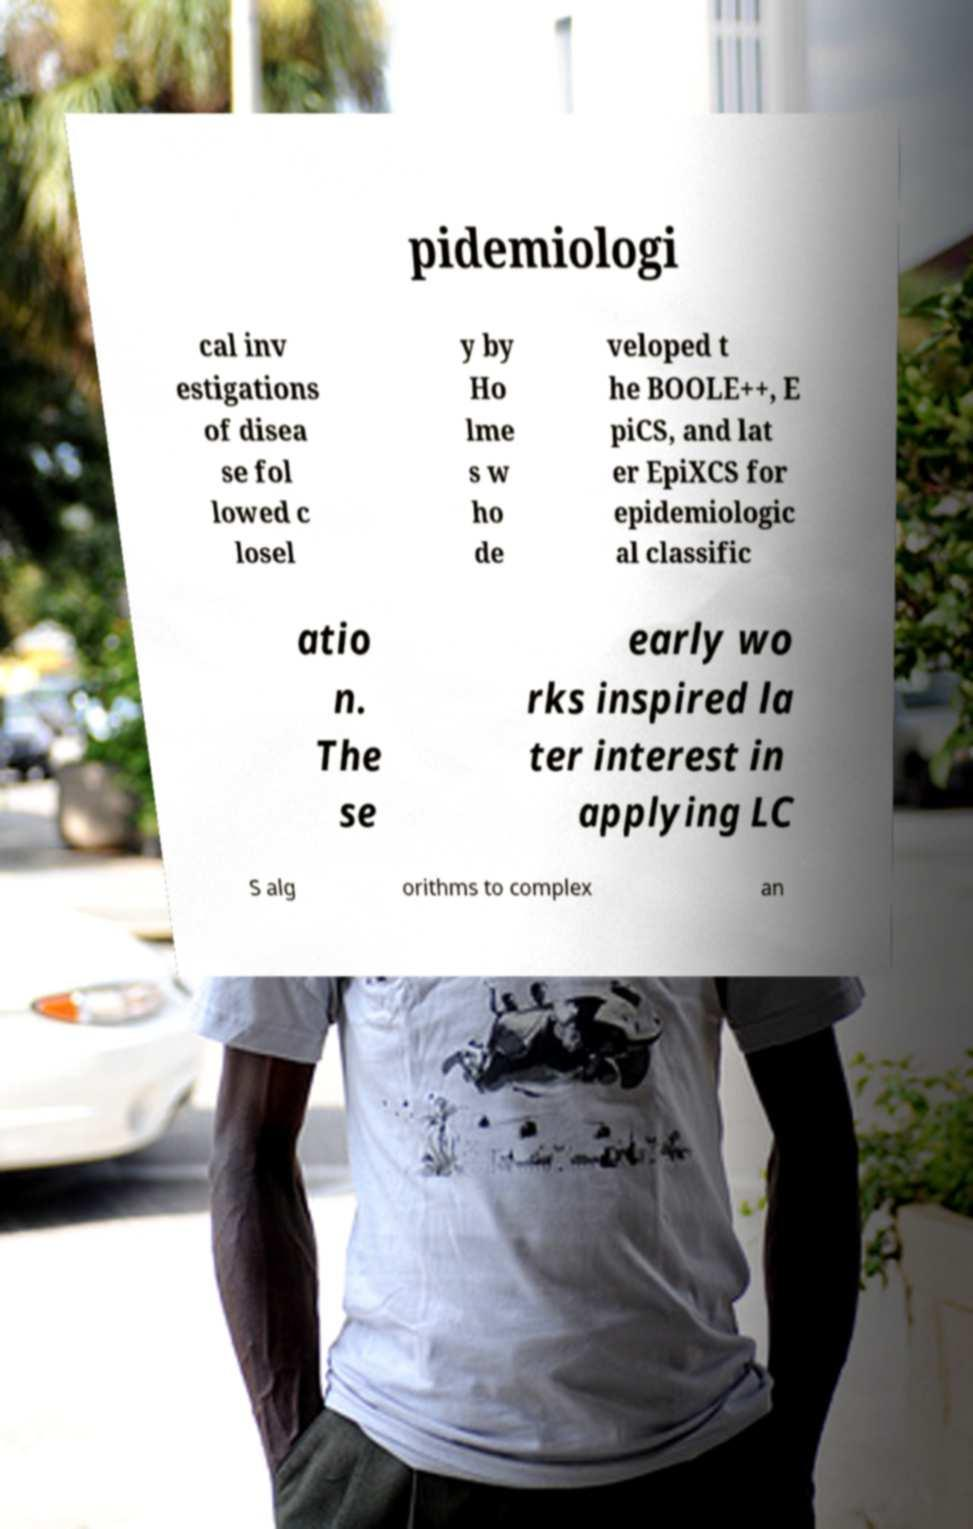For documentation purposes, I need the text within this image transcribed. Could you provide that? pidemiologi cal inv estigations of disea se fol lowed c losel y by Ho lme s w ho de veloped t he BOOLE++, E piCS, and lat er EpiXCS for epidemiologic al classific atio n. The se early wo rks inspired la ter interest in applying LC S alg orithms to complex an 